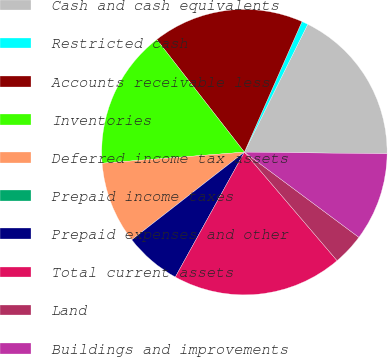<chart> <loc_0><loc_0><loc_500><loc_500><pie_chart><fcel>Cash and cash equivalents<fcel>Restricted cash<fcel>Accounts receivable less<fcel>Inventories<fcel>Deferred income tax assets<fcel>Prepaid income taxes<fcel>Prepaid expenses and other<fcel>Total current assets<fcel>Land<fcel>Buildings and improvements<nl><fcel>17.86%<fcel>0.71%<fcel>17.14%<fcel>15.71%<fcel>9.29%<fcel>0.0%<fcel>6.43%<fcel>19.29%<fcel>3.57%<fcel>10.0%<nl></chart> 